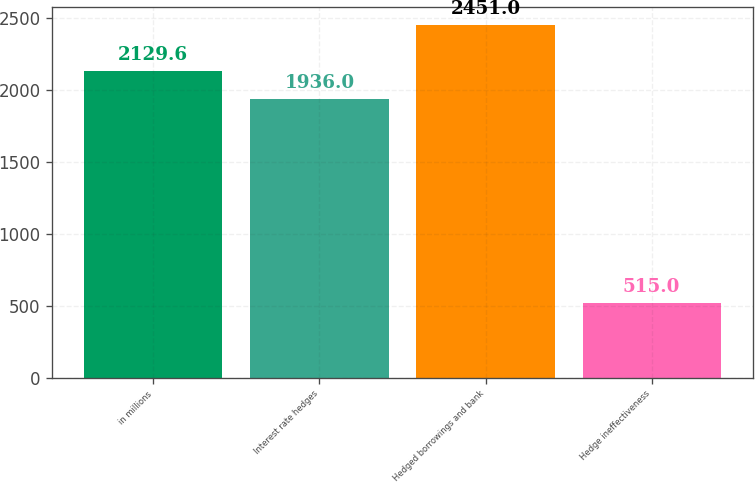Convert chart to OTSL. <chart><loc_0><loc_0><loc_500><loc_500><bar_chart><fcel>in millions<fcel>Interest rate hedges<fcel>Hedged borrowings and bank<fcel>Hedge ineffectiveness<nl><fcel>2129.6<fcel>1936<fcel>2451<fcel>515<nl></chart> 